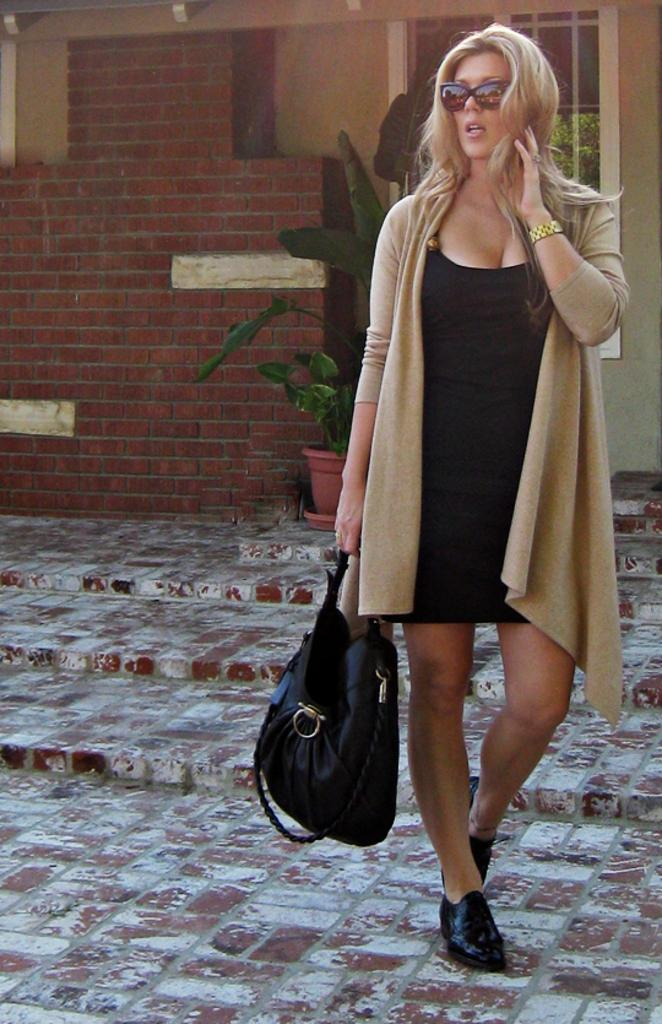Who is present in the image? There is a woman in the image. What is the woman carrying? The woman is carrying a bag. What type of plant can be seen in the image? There is a house plant in the image. What type of structure is visible in the image? There is a building in the image. What is the level of noise in the image? The level of noise cannot be determined from the image, as it does not contain any information about sound. 